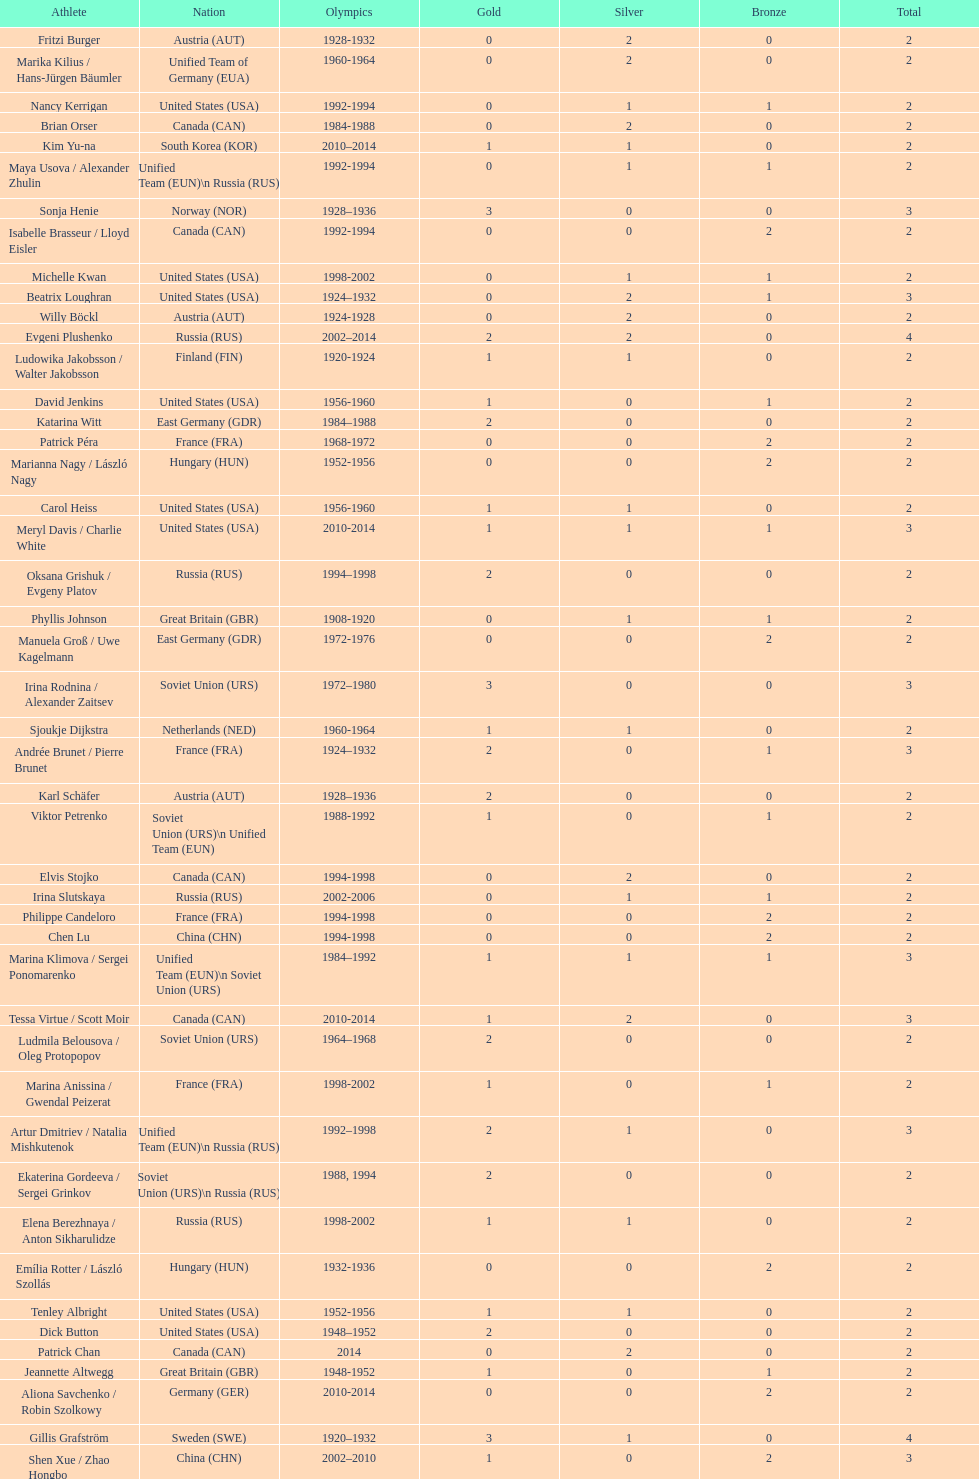How many total medals has the united states won in women's figure skating? 16. 